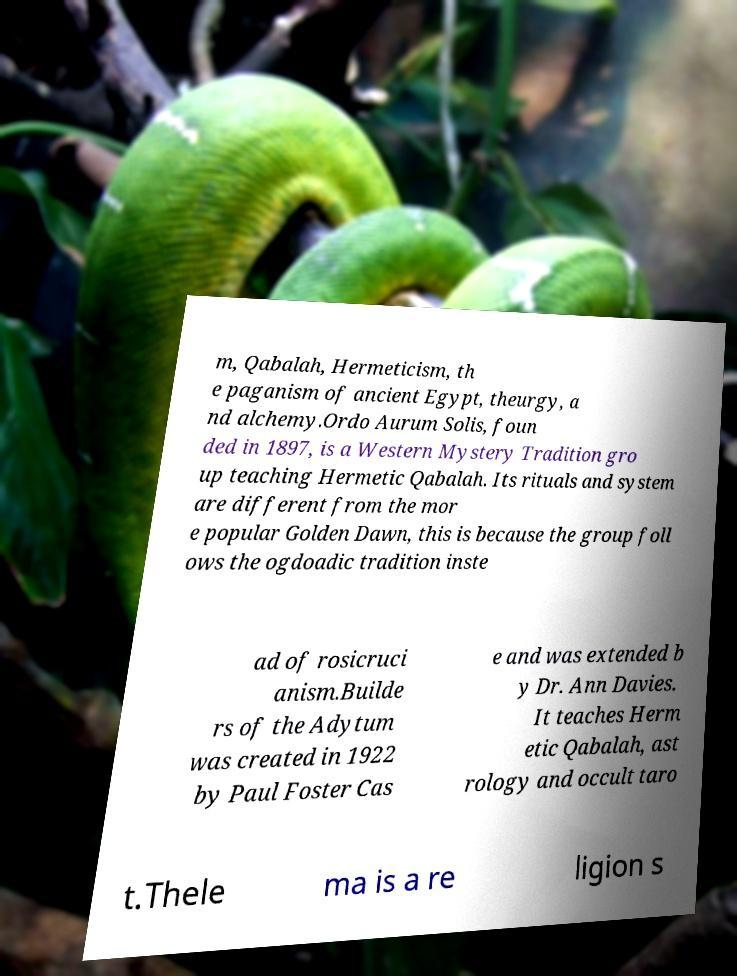There's text embedded in this image that I need extracted. Can you transcribe it verbatim? m, Qabalah, Hermeticism, th e paganism of ancient Egypt, theurgy, a nd alchemy.Ordo Aurum Solis, foun ded in 1897, is a Western Mystery Tradition gro up teaching Hermetic Qabalah. Its rituals and system are different from the mor e popular Golden Dawn, this is because the group foll ows the ogdoadic tradition inste ad of rosicruci anism.Builde rs of the Adytum was created in 1922 by Paul Foster Cas e and was extended b y Dr. Ann Davies. It teaches Herm etic Qabalah, ast rology and occult taro t.Thele ma is a re ligion s 